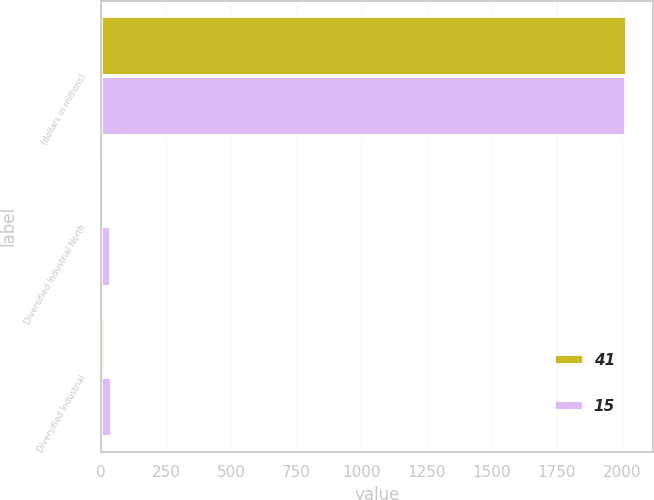Convert chart. <chart><loc_0><loc_0><loc_500><loc_500><stacked_bar_chart><ecel><fcel>(dollars in millions)<fcel>Diversified Industrial North<fcel>Diversified Industrial<nl><fcel>41<fcel>2019<fcel>13<fcel>15<nl><fcel>15<fcel>2018<fcel>37<fcel>41<nl></chart> 